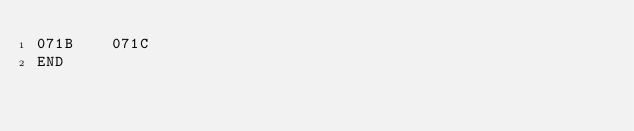Convert code to text. <code><loc_0><loc_0><loc_500><loc_500><_Perl_>071B	071C
END
</code> 